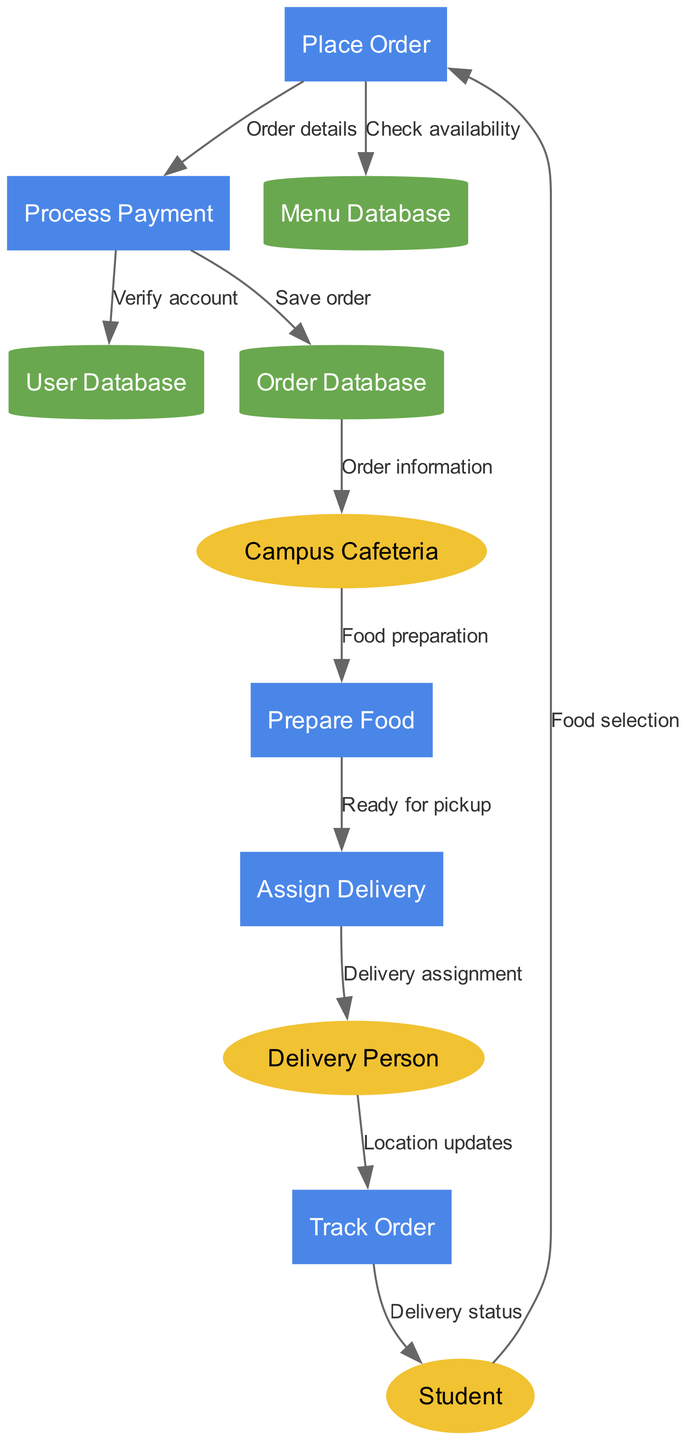What is the starting point for a food delivery order? The starting point is the "Student," as this external entity initiates the process by selecting food and placing an order.
Answer: Student How many processes are involved in the order flow? The diagram includes five processes: "Place Order," "Process Payment," "Prepare Food," "Assign Delivery," and "Track Order." Counting these, we find there are 5 processes.
Answer: 5 Which entity does the "Order information" flow to? The "Order information" flows from the "Order Database" to the "Campus Cafeteria," signifying that the cafeteria receives the details of the order.
Answer: Campus Cafeteria What is required for processing payment in the flow? The "Process Payment" requires "Verify account" which is related to confirming the account details in the "User Database."
Answer: Verify account How is food prepared in the order flow? After the "Order information" arrives at the "Campus Cafeteria," the next step is "Food preparation," indicating that the cafeteria prepares the food.
Answer: Food preparation What kind of updates does the "Delivery Person" provide? The "Delivery Person" provides "Location updates" as they progress through the delivery process which is communicated to "Track Order."
Answer: Location updates What is the final output of the order flow? The final output indicated in the diagram is "Delivery status" which is sent back to the "Student," providing them with the status of their order.
Answer: Delivery status What type of diagram is this? This diagram is specifically a Data Flow Diagram, which denotes the flow of data between entities, processes, and data stores in a system.
Answer: Data Flow Diagram Which data store saves the order information? The "Order Database" is responsible for saving the order information after payment is processed and the order is placed.
Answer: Order Database 